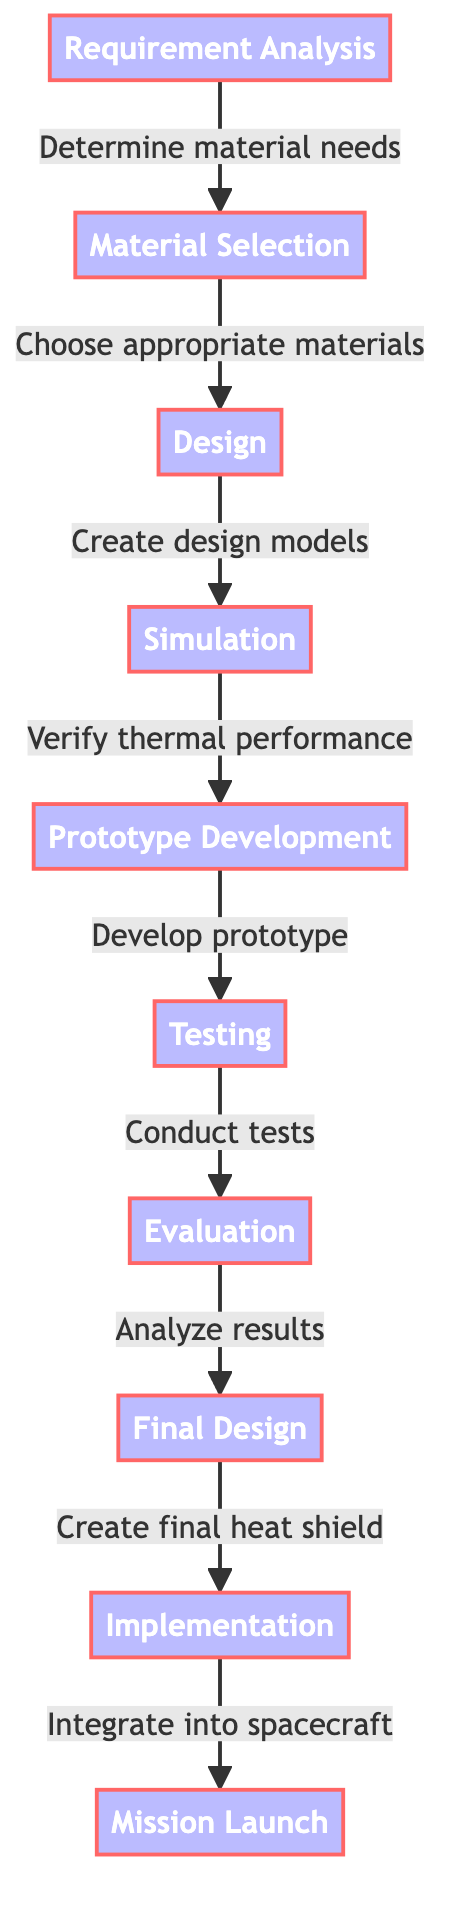What is the first step in the Thermal Protection System development process? The diagram shows that "Requirement Analysis" is the initial step leading to all subsequent steps, marking it as the first node in the flow.
Answer: Requirement Analysis How many total nodes are present in the diagram? The diagram lists a total of 10 nodes, which includes each stage in the Thermal Protection System development process from "Requirement Analysis" to "Mission Launch."
Answer: 10 What action leads from "Design" to "Simulation"? The flow indicates that the transition from "Design" to "Simulation" occurs through the action of creating design models, signified by an arrow pointing from "Design" to "Simulation."
Answer: Create design models What is the last step before "Mission Launch"? The final step specified before "Mission Launch" is "Implementation," as per the directed flow from the preceding steps to the concluding stage.
Answer: Implementation How many steps are involved in the testing phase? The diagram suggests that from "Prototype Development" to "Evaluation," there is one step titled "Conduct tests," indicating there is one major step in the testing phase.
Answer: 1 Which step involves analyzing results? The diagram specifies that "Evaluation" is the step designated for analyzing results, indicated by its placement and the arrow feeding into it from "Testing."
Answer: Evaluation What step directly follows "Final Design"? According to the flow, the step that directly follows "Final Design" is "Implementation," as shown by the arrow leading from one to the other in the diagram.
Answer: Implementation What is the relationship between "Material Selection" and "Design"? The relationship is that "Material Selection" leads to "Design," characterized by the directional arrow indicating that material choices directly influence the design process.
Answer: Leads to What step involves verifying thermal performance? The diagram states that the verification of thermal performance is conducted during the "Simulation" step, marking it as the key phase for this action within the process.
Answer: Simulation 